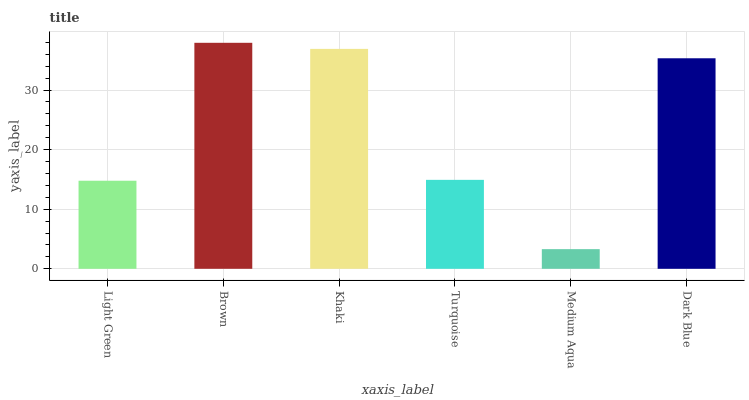Is Medium Aqua the minimum?
Answer yes or no. Yes. Is Brown the maximum?
Answer yes or no. Yes. Is Khaki the minimum?
Answer yes or no. No. Is Khaki the maximum?
Answer yes or no. No. Is Brown greater than Khaki?
Answer yes or no. Yes. Is Khaki less than Brown?
Answer yes or no. Yes. Is Khaki greater than Brown?
Answer yes or no. No. Is Brown less than Khaki?
Answer yes or no. No. Is Dark Blue the high median?
Answer yes or no. Yes. Is Turquoise the low median?
Answer yes or no. Yes. Is Brown the high median?
Answer yes or no. No. Is Dark Blue the low median?
Answer yes or no. No. 